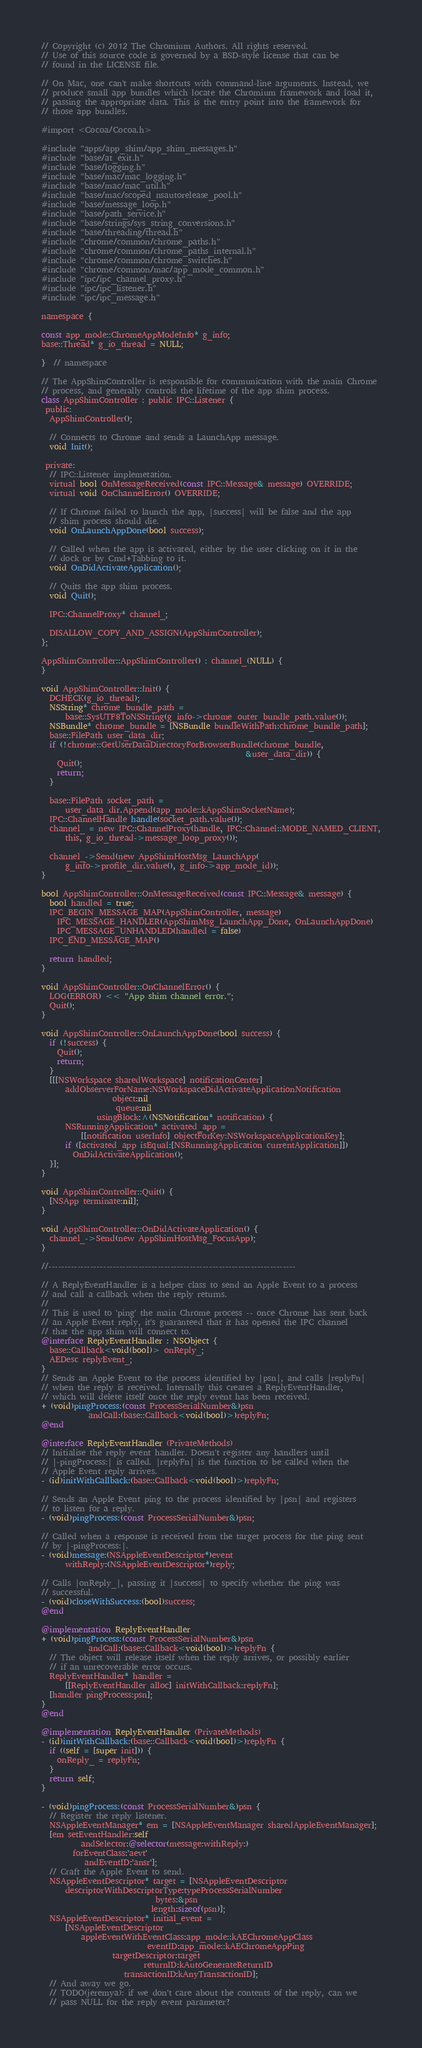<code> <loc_0><loc_0><loc_500><loc_500><_ObjectiveC_>// Copyright (c) 2012 The Chromium Authors. All rights reserved.
// Use of this source code is governed by a BSD-style license that can be
// found in the LICENSE file.

// On Mac, one can't make shortcuts with command-line arguments. Instead, we
// produce small app bundles which locate the Chromium framework and load it,
// passing the appropriate data. This is the entry point into the framework for
// those app bundles.

#import <Cocoa/Cocoa.h>

#include "apps/app_shim/app_shim_messages.h"
#include "base/at_exit.h"
#include "base/logging.h"
#include "base/mac/mac_logging.h"
#include "base/mac/mac_util.h"
#include "base/mac/scoped_nsautorelease_pool.h"
#include "base/message_loop.h"
#include "base/path_service.h"
#include "base/strings/sys_string_conversions.h"
#include "base/threading/thread.h"
#include "chrome/common/chrome_paths.h"
#include "chrome/common/chrome_paths_internal.h"
#include "chrome/common/chrome_switches.h"
#include "chrome/common/mac/app_mode_common.h"
#include "ipc/ipc_channel_proxy.h"
#include "ipc/ipc_listener.h"
#include "ipc/ipc_message.h"

namespace {

const app_mode::ChromeAppModeInfo* g_info;
base::Thread* g_io_thread = NULL;

}  // namespace

// The AppShimController is responsible for communication with the main Chrome
// process, and generally controls the lifetime of the app shim process.
class AppShimController : public IPC::Listener {
 public:
  AppShimController();

  // Connects to Chrome and sends a LaunchApp message.
  void Init();

 private:
  // IPC::Listener implemetation.
  virtual bool OnMessageReceived(const IPC::Message& message) OVERRIDE;
  virtual void OnChannelError() OVERRIDE;

  // If Chrome failed to launch the app, |success| will be false and the app
  // shim process should die.
  void OnLaunchAppDone(bool success);

  // Called when the app is activated, either by the user clicking on it in the
  // dock or by Cmd+Tabbing to it.
  void OnDidActivateApplication();

  // Quits the app shim process.
  void Quit();

  IPC::ChannelProxy* channel_;

  DISALLOW_COPY_AND_ASSIGN(AppShimController);
};

AppShimController::AppShimController() : channel_(NULL) {
}

void AppShimController::Init() {
  DCHECK(g_io_thread);
  NSString* chrome_bundle_path =
      base::SysUTF8ToNSString(g_info->chrome_outer_bundle_path.value());
  NSBundle* chrome_bundle = [NSBundle bundleWithPath:chrome_bundle_path];
  base::FilePath user_data_dir;
  if (!chrome::GetUserDataDirectoryForBrowserBundle(chrome_bundle,
                                                    &user_data_dir)) {
    Quit();
    return;
  }

  base::FilePath socket_path =
      user_data_dir.Append(app_mode::kAppShimSocketName);
  IPC::ChannelHandle handle(socket_path.value());
  channel_ = new IPC::ChannelProxy(handle, IPC::Channel::MODE_NAMED_CLIENT,
      this, g_io_thread->message_loop_proxy());

  channel_->Send(new AppShimHostMsg_LaunchApp(
      g_info->profile_dir.value(), g_info->app_mode_id));
}

bool AppShimController::OnMessageReceived(const IPC::Message& message) {
  bool handled = true;
  IPC_BEGIN_MESSAGE_MAP(AppShimController, message)
    IPC_MESSAGE_HANDLER(AppShimMsg_LaunchApp_Done, OnLaunchAppDone)
    IPC_MESSAGE_UNHANDLED(handled = false)
  IPC_END_MESSAGE_MAP()

  return handled;
}

void AppShimController::OnChannelError() {
  LOG(ERROR) << "App shim channel error.";
  Quit();
}

void AppShimController::OnLaunchAppDone(bool success) {
  if (!success) {
    Quit();
    return;
  }
  [[[NSWorkspace sharedWorkspace] notificationCenter]
      addObserverForName:NSWorkspaceDidActivateApplicationNotification
                  object:nil
                   queue:nil
              usingBlock:^(NSNotification* notification) {
      NSRunningApplication* activated_app =
          [[notification userInfo] objectForKey:NSWorkspaceApplicationKey];
      if ([activated_app isEqual:[NSRunningApplication currentApplication]])
        OnDidActivateApplication();
  }];
}

void AppShimController::Quit() {
  [NSApp terminate:nil];
}

void AppShimController::OnDidActivateApplication() {
  channel_->Send(new AppShimHostMsg_FocusApp);
}

//-----------------------------------------------------------------------------

// A ReplyEventHandler is a helper class to send an Apple Event to a process
// and call a callback when the reply returns.
//
// This is used to 'ping' the main Chrome process -- once Chrome has sent back
// an Apple Event reply, it's guaranteed that it has opened the IPC channel
// that the app shim will connect to.
@interface ReplyEventHandler : NSObject {
  base::Callback<void(bool)> onReply_;
  AEDesc replyEvent_;
}
// Sends an Apple Event to the process identified by |psn|, and calls |replyFn|
// when the reply is received. Internally this creates a ReplyEventHandler,
// which will delete itself once the reply event has been received.
+ (void)pingProcess:(const ProcessSerialNumber&)psn
            andCall:(base::Callback<void(bool)>)replyFn;
@end

@interface ReplyEventHandler (PrivateMethods)
// Initialise the reply event handler. Doesn't register any handlers until
// |-pingProcess:| is called. |replyFn| is the function to be called when the
// Apple Event reply arrives.
- (id)initWithCallback:(base::Callback<void(bool)>)replyFn;

// Sends an Apple Event ping to the process identified by |psn| and registers
// to listen for a reply.
- (void)pingProcess:(const ProcessSerialNumber&)psn;

// Called when a response is received from the target process for the ping sent
// by |-pingProcess:|.
- (void)message:(NSAppleEventDescriptor*)event
      withReply:(NSAppleEventDescriptor*)reply;

// Calls |onReply_|, passing it |success| to specify whether the ping was
// successful.
- (void)closeWithSuccess:(bool)success;
@end

@implementation ReplyEventHandler
+ (void)pingProcess:(const ProcessSerialNumber&)psn
            andCall:(base::Callback<void(bool)>)replyFn {
  // The object will release itself when the reply arrives, or possibly earlier
  // if an unrecoverable error occurs.
  ReplyEventHandler* handler =
      [[ReplyEventHandler alloc] initWithCallback:replyFn];
  [handler pingProcess:psn];
}
@end

@implementation ReplyEventHandler (PrivateMethods)
- (id)initWithCallback:(base::Callback<void(bool)>)replyFn {
  if ((self = [super init])) {
    onReply_ = replyFn;
  }
  return self;
}

- (void)pingProcess:(const ProcessSerialNumber&)psn {
  // Register the reply listener.
  NSAppleEventManager* em = [NSAppleEventManager sharedAppleEventManager];
  [em setEventHandler:self
          andSelector:@selector(message:withReply:)
        forEventClass:'aevt'
           andEventID:'ansr'];
  // Craft the Apple Event to send.
  NSAppleEventDescriptor* target = [NSAppleEventDescriptor
      descriptorWithDescriptorType:typeProcessSerialNumber
                             bytes:&psn
                            length:sizeof(psn)];
  NSAppleEventDescriptor* initial_event =
      [NSAppleEventDescriptor
          appleEventWithEventClass:app_mode::kAEChromeAppClass
                           eventID:app_mode::kAEChromeAppPing
                  targetDescriptor:target
                          returnID:kAutoGenerateReturnID
                     transactionID:kAnyTransactionID];
  // And away we go.
  // TODO(jeremya): if we don't care about the contents of the reply, can we
  // pass NULL for the reply event parameter?</code> 